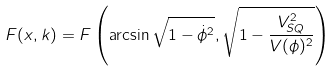Convert formula to latex. <formula><loc_0><loc_0><loc_500><loc_500>F ( x , k ) = F \left ( \arcsin \sqrt { 1 - \dot { \phi } ^ { 2 } } , \sqrt { 1 - \frac { V _ { S Q } ^ { 2 } } { V ( \phi ) ^ { 2 } } } \right )</formula> 